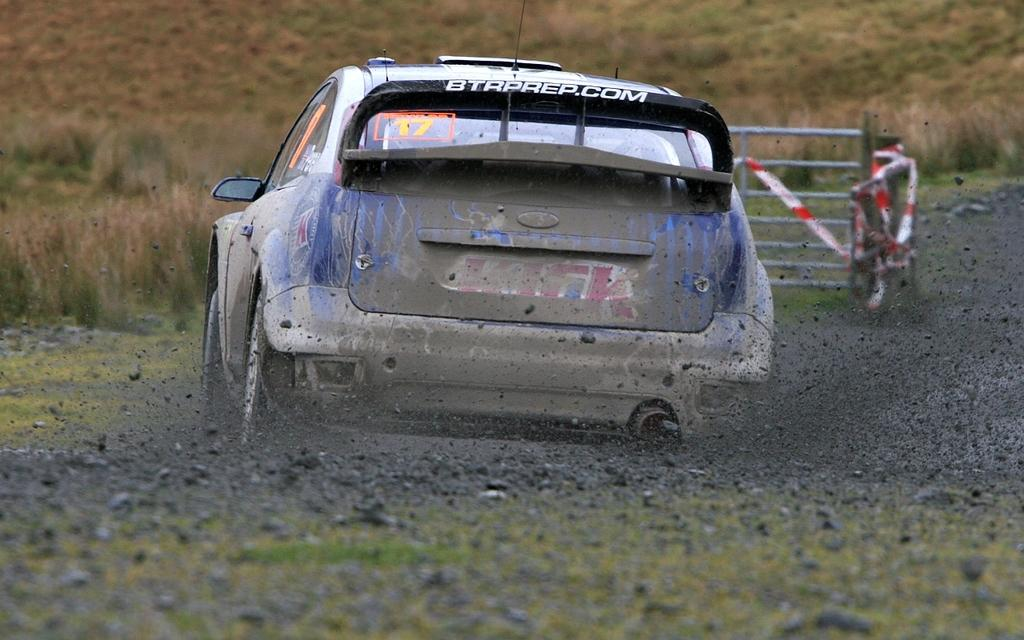What is the main subject of the image? The main subject of the image is a car. What is the car doing in the image? The car is moving on a rocky surface. Can you describe any additional features in the image? There is a railing with stickers in the image. What can be seen in the background of the image? There is grass visible in the background of the image. What type of bead is used to decorate the car's engine in the image? There is no bead or engine present in the image; it features a car moving on a rocky surface with a railing and stickers. What kind of insurance policy is mentioned on the stickers in the image? There is no mention of insurance on the stickers in the image; they are simply decorative. 